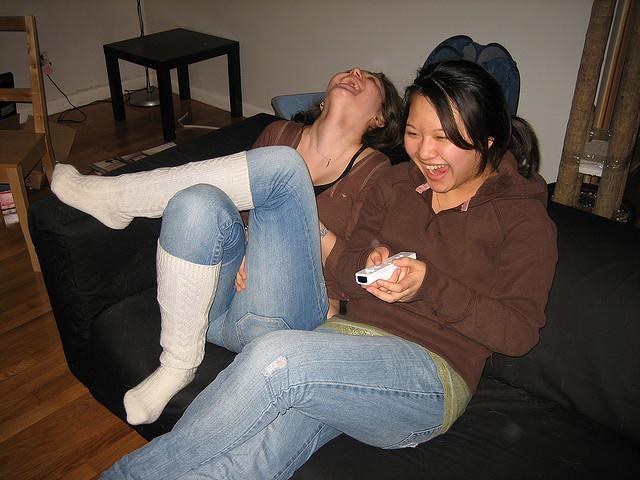How many feet are visible?
Give a very brief answer. 2. How many chairs are in the photo?
Give a very brief answer. 1. How many people are in the picture?
Give a very brief answer. 2. 